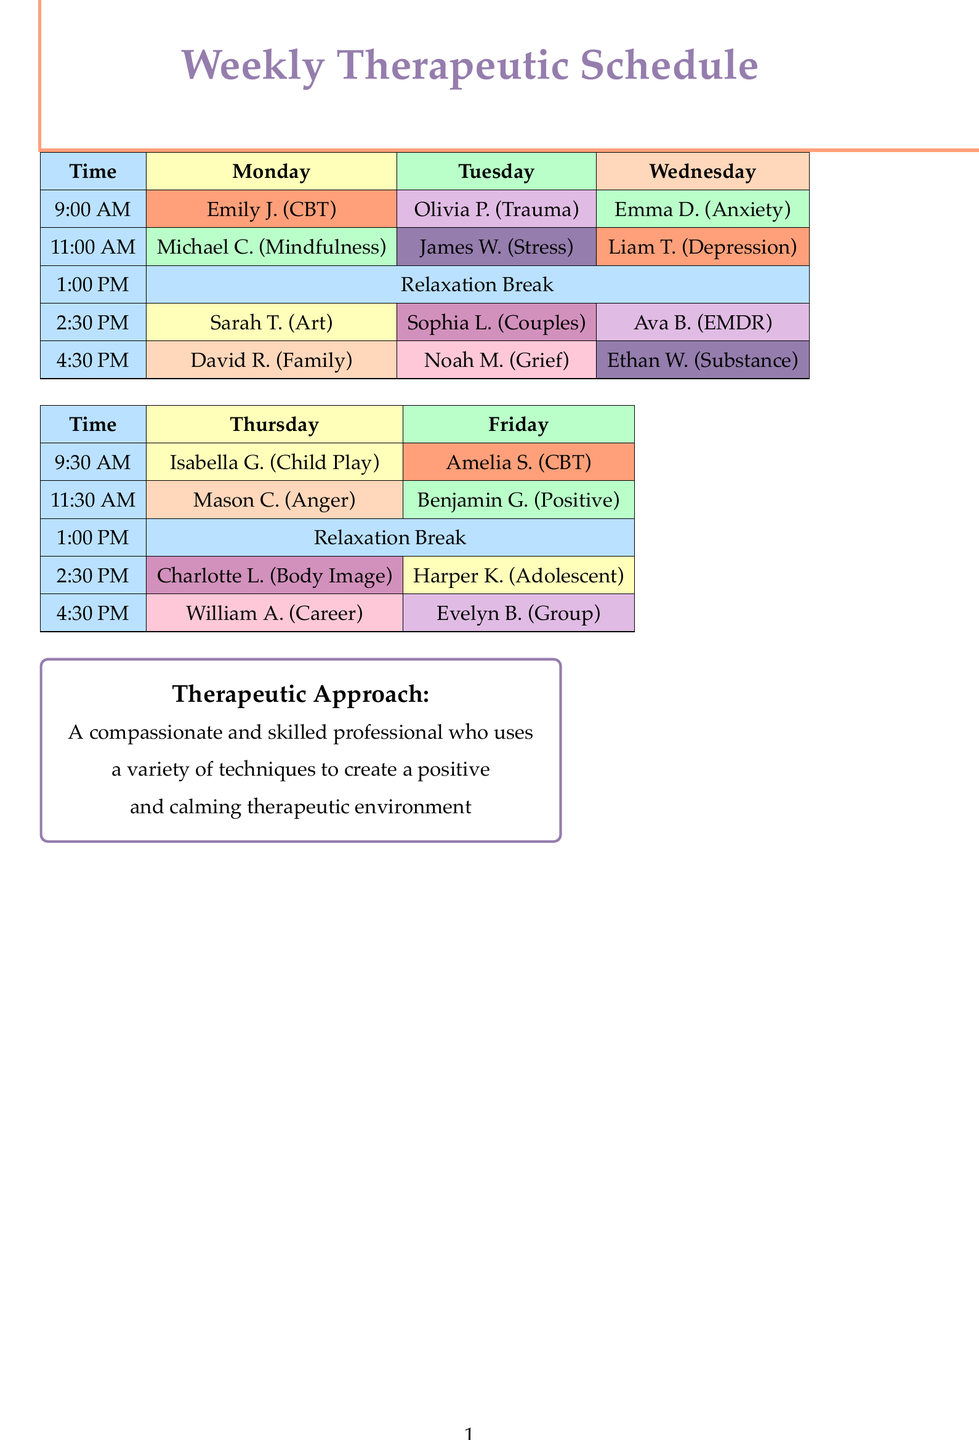What session type does Emily Johnson attend? Emily Johnson attends Cognitive Behavioral Therapy, which is listed under her appointment details.
Answer: Cognitive Behavioral Therapy How many appointments are there on Tuesday? The Tuesday section contains five appointments with clients and activities listed.
Answer: Five What time is the lunch and relaxation break scheduled? The lunch and relaxation break is scheduled for 1:00 PM, which is mentioned in the Monday appointments.
Answer: 1:00 PM Who is scheduled for anxiety management on Wednesday? Ava Brown is the client scheduled for anxiety management during a Wednesday appointment.
Answer: Ava Brown What color code represents the relaxation breaks? The color code for relaxation breaks, as indicated in the appointments, is light blue.
Answer: Light blue Which client has an appointment for couples therapy? Sophia Lee is the client who has an appointment for couples therapy on Tuesday.
Answer: Sophia Lee What session type is scheduled for 4:30 PM on Friday? Evelyn Baker is scheduled for Group Therapy at 5:00 PM, which is confirmed in the Friday appointments.
Answer: Group Therapy On which day is body image counseling scheduled? Body Image Counseling is scheduled for Thursday at 2:30 PM, based on the Thursday appointments.
Answer: Thursday How many different relaxation activities are listed? The document lists five different relaxation activities included in the schedule.
Answer: Five 